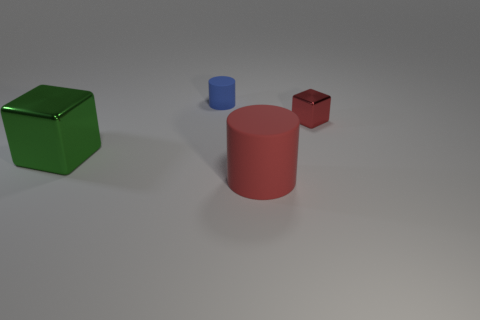Add 1 tiny purple metallic balls. How many objects exist? 5 Subtract 0 cyan cubes. How many objects are left? 4 Subtract all rubber cylinders. Subtract all big green objects. How many objects are left? 1 Add 1 large red cylinders. How many large red cylinders are left? 2 Add 4 gray matte things. How many gray matte things exist? 4 